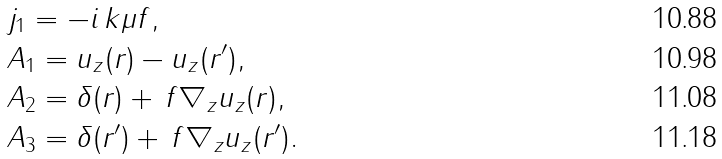<formula> <loc_0><loc_0><loc_500><loc_500>& j _ { 1 } = - i \, k \mu f , \\ & A _ { 1 } = u _ { z } ( r ) - u _ { z } ( r ^ { \prime } ) , \\ & A _ { 2 } = \delta ( r ) + \, f \nabla _ { z } u _ { z } ( r ) , \\ & A _ { 3 } = \delta ( r ^ { \prime } ) + \, f \nabla _ { z } u _ { z } ( r ^ { \prime } ) .</formula> 